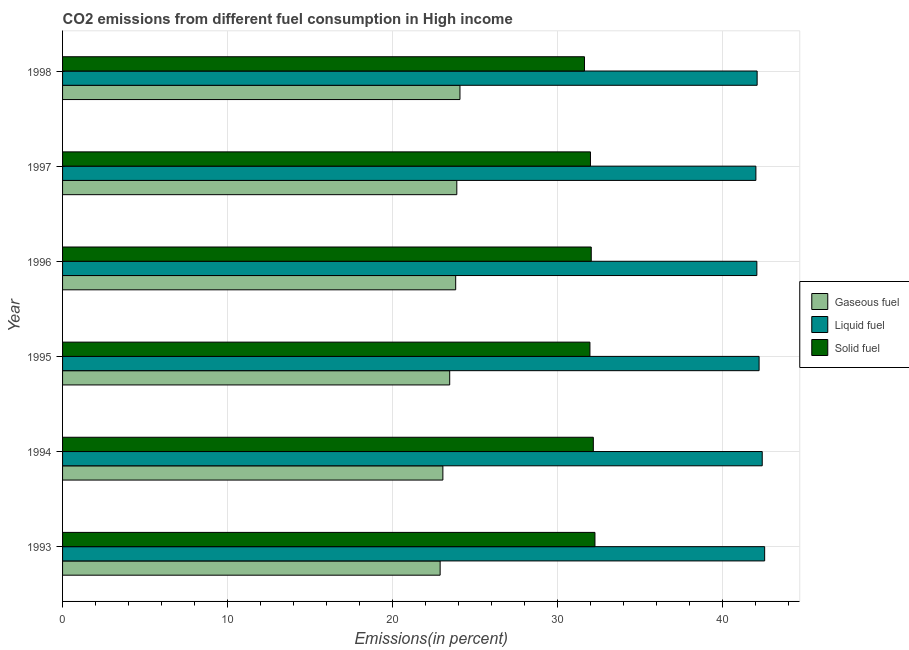Are the number of bars on each tick of the Y-axis equal?
Your answer should be very brief. Yes. How many bars are there on the 6th tick from the top?
Ensure brevity in your answer.  3. In how many cases, is the number of bars for a given year not equal to the number of legend labels?
Your answer should be very brief. 0. What is the percentage of solid fuel emission in 1996?
Your answer should be very brief. 32.02. Across all years, what is the maximum percentage of liquid fuel emission?
Make the answer very short. 42.53. Across all years, what is the minimum percentage of liquid fuel emission?
Offer a very short reply. 42. In which year was the percentage of solid fuel emission maximum?
Provide a succinct answer. 1993. In which year was the percentage of gaseous fuel emission minimum?
Offer a very short reply. 1993. What is the total percentage of liquid fuel emission in the graph?
Provide a short and direct response. 253.22. What is the difference between the percentage of solid fuel emission in 1996 and that in 1998?
Keep it short and to the point. 0.41. What is the difference between the percentage of liquid fuel emission in 1997 and the percentage of solid fuel emission in 1998?
Offer a terse response. 10.38. What is the average percentage of gaseous fuel emission per year?
Provide a short and direct response. 23.52. In the year 1995, what is the difference between the percentage of solid fuel emission and percentage of liquid fuel emission?
Provide a succinct answer. -10.25. Is the difference between the percentage of liquid fuel emission in 1994 and 1997 greater than the difference between the percentage of solid fuel emission in 1994 and 1997?
Your answer should be very brief. Yes. What is the difference between the highest and the second highest percentage of gaseous fuel emission?
Give a very brief answer. 0.19. What is the difference between the highest and the lowest percentage of solid fuel emission?
Provide a succinct answer. 0.63. Is the sum of the percentage of solid fuel emission in 1997 and 1998 greater than the maximum percentage of liquid fuel emission across all years?
Provide a short and direct response. Yes. What does the 1st bar from the top in 1997 represents?
Give a very brief answer. Solid fuel. What does the 1st bar from the bottom in 1993 represents?
Your response must be concise. Gaseous fuel. Is it the case that in every year, the sum of the percentage of gaseous fuel emission and percentage of liquid fuel emission is greater than the percentage of solid fuel emission?
Provide a short and direct response. Yes. How many bars are there?
Make the answer very short. 18. How many years are there in the graph?
Provide a succinct answer. 6. Where does the legend appear in the graph?
Keep it short and to the point. Center right. How many legend labels are there?
Ensure brevity in your answer.  3. How are the legend labels stacked?
Your answer should be very brief. Vertical. What is the title of the graph?
Ensure brevity in your answer.  CO2 emissions from different fuel consumption in High income. Does "Interest" appear as one of the legend labels in the graph?
Keep it short and to the point. No. What is the label or title of the X-axis?
Give a very brief answer. Emissions(in percent). What is the Emissions(in percent) in Gaseous fuel in 1993?
Your answer should be very brief. 22.87. What is the Emissions(in percent) in Liquid fuel in 1993?
Provide a succinct answer. 42.53. What is the Emissions(in percent) of Solid fuel in 1993?
Your response must be concise. 32.25. What is the Emissions(in percent) in Gaseous fuel in 1994?
Offer a very short reply. 23.04. What is the Emissions(in percent) in Liquid fuel in 1994?
Provide a succinct answer. 42.38. What is the Emissions(in percent) of Solid fuel in 1994?
Provide a succinct answer. 32.15. What is the Emissions(in percent) of Gaseous fuel in 1995?
Your answer should be very brief. 23.45. What is the Emissions(in percent) in Liquid fuel in 1995?
Your response must be concise. 42.19. What is the Emissions(in percent) of Solid fuel in 1995?
Keep it short and to the point. 31.94. What is the Emissions(in percent) in Gaseous fuel in 1996?
Your response must be concise. 23.81. What is the Emissions(in percent) of Liquid fuel in 1996?
Your response must be concise. 42.05. What is the Emissions(in percent) of Solid fuel in 1996?
Keep it short and to the point. 32.02. What is the Emissions(in percent) in Gaseous fuel in 1997?
Offer a terse response. 23.88. What is the Emissions(in percent) in Liquid fuel in 1997?
Provide a succinct answer. 42. What is the Emissions(in percent) of Solid fuel in 1997?
Your answer should be very brief. 31.98. What is the Emissions(in percent) of Gaseous fuel in 1998?
Your answer should be compact. 24.07. What is the Emissions(in percent) in Liquid fuel in 1998?
Your answer should be compact. 42.07. What is the Emissions(in percent) in Solid fuel in 1998?
Your response must be concise. 31.61. Across all years, what is the maximum Emissions(in percent) of Gaseous fuel?
Your answer should be very brief. 24.07. Across all years, what is the maximum Emissions(in percent) of Liquid fuel?
Your answer should be very brief. 42.53. Across all years, what is the maximum Emissions(in percent) in Solid fuel?
Offer a very short reply. 32.25. Across all years, what is the minimum Emissions(in percent) of Gaseous fuel?
Offer a very short reply. 22.87. Across all years, what is the minimum Emissions(in percent) of Liquid fuel?
Ensure brevity in your answer.  42. Across all years, what is the minimum Emissions(in percent) in Solid fuel?
Your response must be concise. 31.61. What is the total Emissions(in percent) of Gaseous fuel in the graph?
Keep it short and to the point. 141.12. What is the total Emissions(in percent) of Liquid fuel in the graph?
Give a very brief answer. 253.22. What is the total Emissions(in percent) in Solid fuel in the graph?
Give a very brief answer. 191.95. What is the difference between the Emissions(in percent) of Gaseous fuel in 1993 and that in 1994?
Your answer should be compact. -0.17. What is the difference between the Emissions(in percent) in Liquid fuel in 1993 and that in 1994?
Keep it short and to the point. 0.15. What is the difference between the Emissions(in percent) in Solid fuel in 1993 and that in 1994?
Your answer should be compact. 0.1. What is the difference between the Emissions(in percent) of Gaseous fuel in 1993 and that in 1995?
Ensure brevity in your answer.  -0.58. What is the difference between the Emissions(in percent) of Liquid fuel in 1993 and that in 1995?
Your response must be concise. 0.34. What is the difference between the Emissions(in percent) of Solid fuel in 1993 and that in 1995?
Give a very brief answer. 0.3. What is the difference between the Emissions(in percent) in Gaseous fuel in 1993 and that in 1996?
Ensure brevity in your answer.  -0.94. What is the difference between the Emissions(in percent) of Liquid fuel in 1993 and that in 1996?
Offer a very short reply. 0.47. What is the difference between the Emissions(in percent) of Solid fuel in 1993 and that in 1996?
Offer a terse response. 0.22. What is the difference between the Emissions(in percent) of Gaseous fuel in 1993 and that in 1997?
Provide a succinct answer. -1.01. What is the difference between the Emissions(in percent) in Liquid fuel in 1993 and that in 1997?
Your answer should be very brief. 0.53. What is the difference between the Emissions(in percent) of Solid fuel in 1993 and that in 1997?
Your answer should be very brief. 0.27. What is the difference between the Emissions(in percent) in Gaseous fuel in 1993 and that in 1998?
Keep it short and to the point. -1.2. What is the difference between the Emissions(in percent) in Liquid fuel in 1993 and that in 1998?
Your answer should be very brief. 0.46. What is the difference between the Emissions(in percent) in Solid fuel in 1993 and that in 1998?
Provide a succinct answer. 0.63. What is the difference between the Emissions(in percent) of Gaseous fuel in 1994 and that in 1995?
Make the answer very short. -0.41. What is the difference between the Emissions(in percent) in Liquid fuel in 1994 and that in 1995?
Provide a succinct answer. 0.19. What is the difference between the Emissions(in percent) of Solid fuel in 1994 and that in 1995?
Offer a terse response. 0.21. What is the difference between the Emissions(in percent) in Gaseous fuel in 1994 and that in 1996?
Your answer should be compact. -0.78. What is the difference between the Emissions(in percent) of Liquid fuel in 1994 and that in 1996?
Your response must be concise. 0.33. What is the difference between the Emissions(in percent) of Solid fuel in 1994 and that in 1996?
Your response must be concise. 0.13. What is the difference between the Emissions(in percent) in Gaseous fuel in 1994 and that in 1997?
Your response must be concise. -0.84. What is the difference between the Emissions(in percent) in Liquid fuel in 1994 and that in 1997?
Give a very brief answer. 0.38. What is the difference between the Emissions(in percent) of Solid fuel in 1994 and that in 1997?
Provide a short and direct response. 0.17. What is the difference between the Emissions(in percent) of Gaseous fuel in 1994 and that in 1998?
Offer a terse response. -1.04. What is the difference between the Emissions(in percent) in Liquid fuel in 1994 and that in 1998?
Provide a succinct answer. 0.31. What is the difference between the Emissions(in percent) of Solid fuel in 1994 and that in 1998?
Keep it short and to the point. 0.54. What is the difference between the Emissions(in percent) in Gaseous fuel in 1995 and that in 1996?
Provide a succinct answer. -0.36. What is the difference between the Emissions(in percent) of Liquid fuel in 1995 and that in 1996?
Offer a very short reply. 0.14. What is the difference between the Emissions(in percent) in Solid fuel in 1995 and that in 1996?
Ensure brevity in your answer.  -0.08. What is the difference between the Emissions(in percent) in Gaseous fuel in 1995 and that in 1997?
Offer a terse response. -0.43. What is the difference between the Emissions(in percent) of Liquid fuel in 1995 and that in 1997?
Provide a succinct answer. 0.19. What is the difference between the Emissions(in percent) of Solid fuel in 1995 and that in 1997?
Your response must be concise. -0.03. What is the difference between the Emissions(in percent) of Gaseous fuel in 1995 and that in 1998?
Your answer should be compact. -0.62. What is the difference between the Emissions(in percent) of Liquid fuel in 1995 and that in 1998?
Your answer should be very brief. 0.12. What is the difference between the Emissions(in percent) in Solid fuel in 1995 and that in 1998?
Provide a succinct answer. 0.33. What is the difference between the Emissions(in percent) of Gaseous fuel in 1996 and that in 1997?
Your answer should be compact. -0.07. What is the difference between the Emissions(in percent) of Liquid fuel in 1996 and that in 1997?
Offer a terse response. 0.06. What is the difference between the Emissions(in percent) of Solid fuel in 1996 and that in 1997?
Offer a terse response. 0.05. What is the difference between the Emissions(in percent) in Gaseous fuel in 1996 and that in 1998?
Your response must be concise. -0.26. What is the difference between the Emissions(in percent) of Liquid fuel in 1996 and that in 1998?
Give a very brief answer. -0.02. What is the difference between the Emissions(in percent) in Solid fuel in 1996 and that in 1998?
Give a very brief answer. 0.41. What is the difference between the Emissions(in percent) of Gaseous fuel in 1997 and that in 1998?
Give a very brief answer. -0.19. What is the difference between the Emissions(in percent) of Liquid fuel in 1997 and that in 1998?
Provide a short and direct response. -0.08. What is the difference between the Emissions(in percent) of Solid fuel in 1997 and that in 1998?
Your response must be concise. 0.36. What is the difference between the Emissions(in percent) in Gaseous fuel in 1993 and the Emissions(in percent) in Liquid fuel in 1994?
Offer a terse response. -19.51. What is the difference between the Emissions(in percent) in Gaseous fuel in 1993 and the Emissions(in percent) in Solid fuel in 1994?
Provide a succinct answer. -9.28. What is the difference between the Emissions(in percent) in Liquid fuel in 1993 and the Emissions(in percent) in Solid fuel in 1994?
Provide a succinct answer. 10.38. What is the difference between the Emissions(in percent) in Gaseous fuel in 1993 and the Emissions(in percent) in Liquid fuel in 1995?
Make the answer very short. -19.32. What is the difference between the Emissions(in percent) of Gaseous fuel in 1993 and the Emissions(in percent) of Solid fuel in 1995?
Provide a short and direct response. -9.07. What is the difference between the Emissions(in percent) of Liquid fuel in 1993 and the Emissions(in percent) of Solid fuel in 1995?
Make the answer very short. 10.58. What is the difference between the Emissions(in percent) in Gaseous fuel in 1993 and the Emissions(in percent) in Liquid fuel in 1996?
Ensure brevity in your answer.  -19.18. What is the difference between the Emissions(in percent) in Gaseous fuel in 1993 and the Emissions(in percent) in Solid fuel in 1996?
Your response must be concise. -9.15. What is the difference between the Emissions(in percent) of Liquid fuel in 1993 and the Emissions(in percent) of Solid fuel in 1996?
Your response must be concise. 10.5. What is the difference between the Emissions(in percent) of Gaseous fuel in 1993 and the Emissions(in percent) of Liquid fuel in 1997?
Keep it short and to the point. -19.13. What is the difference between the Emissions(in percent) in Gaseous fuel in 1993 and the Emissions(in percent) in Solid fuel in 1997?
Provide a short and direct response. -9.11. What is the difference between the Emissions(in percent) of Liquid fuel in 1993 and the Emissions(in percent) of Solid fuel in 1997?
Keep it short and to the point. 10.55. What is the difference between the Emissions(in percent) of Gaseous fuel in 1993 and the Emissions(in percent) of Liquid fuel in 1998?
Provide a succinct answer. -19.2. What is the difference between the Emissions(in percent) of Gaseous fuel in 1993 and the Emissions(in percent) of Solid fuel in 1998?
Your answer should be compact. -8.74. What is the difference between the Emissions(in percent) of Liquid fuel in 1993 and the Emissions(in percent) of Solid fuel in 1998?
Offer a very short reply. 10.91. What is the difference between the Emissions(in percent) in Gaseous fuel in 1994 and the Emissions(in percent) in Liquid fuel in 1995?
Your answer should be compact. -19.15. What is the difference between the Emissions(in percent) of Gaseous fuel in 1994 and the Emissions(in percent) of Solid fuel in 1995?
Offer a terse response. -8.91. What is the difference between the Emissions(in percent) of Liquid fuel in 1994 and the Emissions(in percent) of Solid fuel in 1995?
Provide a succinct answer. 10.44. What is the difference between the Emissions(in percent) in Gaseous fuel in 1994 and the Emissions(in percent) in Liquid fuel in 1996?
Give a very brief answer. -19.02. What is the difference between the Emissions(in percent) in Gaseous fuel in 1994 and the Emissions(in percent) in Solid fuel in 1996?
Ensure brevity in your answer.  -8.99. What is the difference between the Emissions(in percent) of Liquid fuel in 1994 and the Emissions(in percent) of Solid fuel in 1996?
Your response must be concise. 10.36. What is the difference between the Emissions(in percent) of Gaseous fuel in 1994 and the Emissions(in percent) of Liquid fuel in 1997?
Provide a succinct answer. -18.96. What is the difference between the Emissions(in percent) in Gaseous fuel in 1994 and the Emissions(in percent) in Solid fuel in 1997?
Give a very brief answer. -8.94. What is the difference between the Emissions(in percent) of Liquid fuel in 1994 and the Emissions(in percent) of Solid fuel in 1997?
Give a very brief answer. 10.4. What is the difference between the Emissions(in percent) in Gaseous fuel in 1994 and the Emissions(in percent) in Liquid fuel in 1998?
Keep it short and to the point. -19.04. What is the difference between the Emissions(in percent) of Gaseous fuel in 1994 and the Emissions(in percent) of Solid fuel in 1998?
Offer a terse response. -8.58. What is the difference between the Emissions(in percent) of Liquid fuel in 1994 and the Emissions(in percent) of Solid fuel in 1998?
Give a very brief answer. 10.77. What is the difference between the Emissions(in percent) in Gaseous fuel in 1995 and the Emissions(in percent) in Liquid fuel in 1996?
Give a very brief answer. -18.61. What is the difference between the Emissions(in percent) in Gaseous fuel in 1995 and the Emissions(in percent) in Solid fuel in 1996?
Give a very brief answer. -8.57. What is the difference between the Emissions(in percent) in Liquid fuel in 1995 and the Emissions(in percent) in Solid fuel in 1996?
Offer a terse response. 10.17. What is the difference between the Emissions(in percent) in Gaseous fuel in 1995 and the Emissions(in percent) in Liquid fuel in 1997?
Make the answer very short. -18.55. What is the difference between the Emissions(in percent) of Gaseous fuel in 1995 and the Emissions(in percent) of Solid fuel in 1997?
Keep it short and to the point. -8.53. What is the difference between the Emissions(in percent) in Liquid fuel in 1995 and the Emissions(in percent) in Solid fuel in 1997?
Provide a short and direct response. 10.21. What is the difference between the Emissions(in percent) of Gaseous fuel in 1995 and the Emissions(in percent) of Liquid fuel in 1998?
Give a very brief answer. -18.62. What is the difference between the Emissions(in percent) of Gaseous fuel in 1995 and the Emissions(in percent) of Solid fuel in 1998?
Provide a short and direct response. -8.16. What is the difference between the Emissions(in percent) in Liquid fuel in 1995 and the Emissions(in percent) in Solid fuel in 1998?
Your response must be concise. 10.58. What is the difference between the Emissions(in percent) in Gaseous fuel in 1996 and the Emissions(in percent) in Liquid fuel in 1997?
Offer a very short reply. -18.18. What is the difference between the Emissions(in percent) in Gaseous fuel in 1996 and the Emissions(in percent) in Solid fuel in 1997?
Your answer should be compact. -8.16. What is the difference between the Emissions(in percent) in Liquid fuel in 1996 and the Emissions(in percent) in Solid fuel in 1997?
Make the answer very short. 10.08. What is the difference between the Emissions(in percent) in Gaseous fuel in 1996 and the Emissions(in percent) in Liquid fuel in 1998?
Your answer should be very brief. -18.26. What is the difference between the Emissions(in percent) of Gaseous fuel in 1996 and the Emissions(in percent) of Solid fuel in 1998?
Offer a very short reply. -7.8. What is the difference between the Emissions(in percent) in Liquid fuel in 1996 and the Emissions(in percent) in Solid fuel in 1998?
Provide a succinct answer. 10.44. What is the difference between the Emissions(in percent) of Gaseous fuel in 1997 and the Emissions(in percent) of Liquid fuel in 1998?
Your response must be concise. -18.19. What is the difference between the Emissions(in percent) in Gaseous fuel in 1997 and the Emissions(in percent) in Solid fuel in 1998?
Offer a very short reply. -7.73. What is the difference between the Emissions(in percent) in Liquid fuel in 1997 and the Emissions(in percent) in Solid fuel in 1998?
Make the answer very short. 10.38. What is the average Emissions(in percent) in Gaseous fuel per year?
Your answer should be very brief. 23.52. What is the average Emissions(in percent) of Liquid fuel per year?
Your answer should be very brief. 42.2. What is the average Emissions(in percent) of Solid fuel per year?
Provide a short and direct response. 31.99. In the year 1993, what is the difference between the Emissions(in percent) in Gaseous fuel and Emissions(in percent) in Liquid fuel?
Provide a short and direct response. -19.66. In the year 1993, what is the difference between the Emissions(in percent) of Gaseous fuel and Emissions(in percent) of Solid fuel?
Give a very brief answer. -9.38. In the year 1993, what is the difference between the Emissions(in percent) of Liquid fuel and Emissions(in percent) of Solid fuel?
Your answer should be compact. 10.28. In the year 1994, what is the difference between the Emissions(in percent) in Gaseous fuel and Emissions(in percent) in Liquid fuel?
Offer a very short reply. -19.34. In the year 1994, what is the difference between the Emissions(in percent) of Gaseous fuel and Emissions(in percent) of Solid fuel?
Provide a short and direct response. -9.11. In the year 1994, what is the difference between the Emissions(in percent) in Liquid fuel and Emissions(in percent) in Solid fuel?
Give a very brief answer. 10.23. In the year 1995, what is the difference between the Emissions(in percent) in Gaseous fuel and Emissions(in percent) in Liquid fuel?
Offer a terse response. -18.74. In the year 1995, what is the difference between the Emissions(in percent) of Gaseous fuel and Emissions(in percent) of Solid fuel?
Your response must be concise. -8.49. In the year 1995, what is the difference between the Emissions(in percent) of Liquid fuel and Emissions(in percent) of Solid fuel?
Your answer should be compact. 10.25. In the year 1996, what is the difference between the Emissions(in percent) in Gaseous fuel and Emissions(in percent) in Liquid fuel?
Keep it short and to the point. -18.24. In the year 1996, what is the difference between the Emissions(in percent) of Gaseous fuel and Emissions(in percent) of Solid fuel?
Give a very brief answer. -8.21. In the year 1996, what is the difference between the Emissions(in percent) in Liquid fuel and Emissions(in percent) in Solid fuel?
Give a very brief answer. 10.03. In the year 1997, what is the difference between the Emissions(in percent) of Gaseous fuel and Emissions(in percent) of Liquid fuel?
Ensure brevity in your answer.  -18.12. In the year 1997, what is the difference between the Emissions(in percent) of Gaseous fuel and Emissions(in percent) of Solid fuel?
Provide a short and direct response. -8.1. In the year 1997, what is the difference between the Emissions(in percent) of Liquid fuel and Emissions(in percent) of Solid fuel?
Your answer should be compact. 10.02. In the year 1998, what is the difference between the Emissions(in percent) in Gaseous fuel and Emissions(in percent) in Liquid fuel?
Provide a succinct answer. -18. In the year 1998, what is the difference between the Emissions(in percent) in Gaseous fuel and Emissions(in percent) in Solid fuel?
Keep it short and to the point. -7.54. In the year 1998, what is the difference between the Emissions(in percent) of Liquid fuel and Emissions(in percent) of Solid fuel?
Provide a succinct answer. 10.46. What is the ratio of the Emissions(in percent) in Gaseous fuel in 1993 to that in 1994?
Offer a very short reply. 0.99. What is the ratio of the Emissions(in percent) of Solid fuel in 1993 to that in 1994?
Offer a very short reply. 1. What is the ratio of the Emissions(in percent) in Gaseous fuel in 1993 to that in 1995?
Your answer should be very brief. 0.98. What is the ratio of the Emissions(in percent) in Liquid fuel in 1993 to that in 1995?
Your answer should be compact. 1.01. What is the ratio of the Emissions(in percent) in Solid fuel in 1993 to that in 1995?
Your answer should be compact. 1.01. What is the ratio of the Emissions(in percent) in Gaseous fuel in 1993 to that in 1996?
Make the answer very short. 0.96. What is the ratio of the Emissions(in percent) in Liquid fuel in 1993 to that in 1996?
Make the answer very short. 1.01. What is the ratio of the Emissions(in percent) in Gaseous fuel in 1993 to that in 1997?
Offer a terse response. 0.96. What is the ratio of the Emissions(in percent) in Liquid fuel in 1993 to that in 1997?
Your answer should be compact. 1.01. What is the ratio of the Emissions(in percent) in Solid fuel in 1993 to that in 1997?
Provide a short and direct response. 1.01. What is the ratio of the Emissions(in percent) of Gaseous fuel in 1993 to that in 1998?
Your answer should be compact. 0.95. What is the ratio of the Emissions(in percent) of Liquid fuel in 1993 to that in 1998?
Make the answer very short. 1.01. What is the ratio of the Emissions(in percent) in Solid fuel in 1993 to that in 1998?
Provide a succinct answer. 1.02. What is the ratio of the Emissions(in percent) of Gaseous fuel in 1994 to that in 1995?
Ensure brevity in your answer.  0.98. What is the ratio of the Emissions(in percent) in Liquid fuel in 1994 to that in 1995?
Your answer should be very brief. 1. What is the ratio of the Emissions(in percent) in Solid fuel in 1994 to that in 1995?
Ensure brevity in your answer.  1.01. What is the ratio of the Emissions(in percent) in Gaseous fuel in 1994 to that in 1996?
Make the answer very short. 0.97. What is the ratio of the Emissions(in percent) of Liquid fuel in 1994 to that in 1996?
Keep it short and to the point. 1.01. What is the ratio of the Emissions(in percent) of Gaseous fuel in 1994 to that in 1997?
Your response must be concise. 0.96. What is the ratio of the Emissions(in percent) in Liquid fuel in 1994 to that in 1997?
Your response must be concise. 1.01. What is the ratio of the Emissions(in percent) of Solid fuel in 1994 to that in 1997?
Give a very brief answer. 1.01. What is the ratio of the Emissions(in percent) in Gaseous fuel in 1994 to that in 1998?
Your answer should be compact. 0.96. What is the ratio of the Emissions(in percent) of Liquid fuel in 1994 to that in 1998?
Provide a short and direct response. 1.01. What is the ratio of the Emissions(in percent) in Solid fuel in 1994 to that in 1998?
Provide a short and direct response. 1.02. What is the ratio of the Emissions(in percent) of Liquid fuel in 1995 to that in 1996?
Offer a terse response. 1. What is the ratio of the Emissions(in percent) of Solid fuel in 1995 to that in 1996?
Keep it short and to the point. 1. What is the ratio of the Emissions(in percent) in Gaseous fuel in 1995 to that in 1997?
Your response must be concise. 0.98. What is the ratio of the Emissions(in percent) of Solid fuel in 1995 to that in 1997?
Offer a very short reply. 1. What is the ratio of the Emissions(in percent) in Gaseous fuel in 1995 to that in 1998?
Provide a short and direct response. 0.97. What is the ratio of the Emissions(in percent) in Solid fuel in 1995 to that in 1998?
Your response must be concise. 1.01. What is the ratio of the Emissions(in percent) of Gaseous fuel in 1996 to that in 1997?
Keep it short and to the point. 1. What is the ratio of the Emissions(in percent) of Solid fuel in 1996 to that in 1997?
Offer a very short reply. 1. What is the ratio of the Emissions(in percent) in Liquid fuel in 1997 to that in 1998?
Make the answer very short. 1. What is the ratio of the Emissions(in percent) of Solid fuel in 1997 to that in 1998?
Your response must be concise. 1.01. What is the difference between the highest and the second highest Emissions(in percent) in Gaseous fuel?
Ensure brevity in your answer.  0.19. What is the difference between the highest and the second highest Emissions(in percent) of Liquid fuel?
Give a very brief answer. 0.15. What is the difference between the highest and the second highest Emissions(in percent) of Solid fuel?
Offer a terse response. 0.1. What is the difference between the highest and the lowest Emissions(in percent) in Gaseous fuel?
Make the answer very short. 1.2. What is the difference between the highest and the lowest Emissions(in percent) of Liquid fuel?
Keep it short and to the point. 0.53. What is the difference between the highest and the lowest Emissions(in percent) in Solid fuel?
Offer a very short reply. 0.63. 